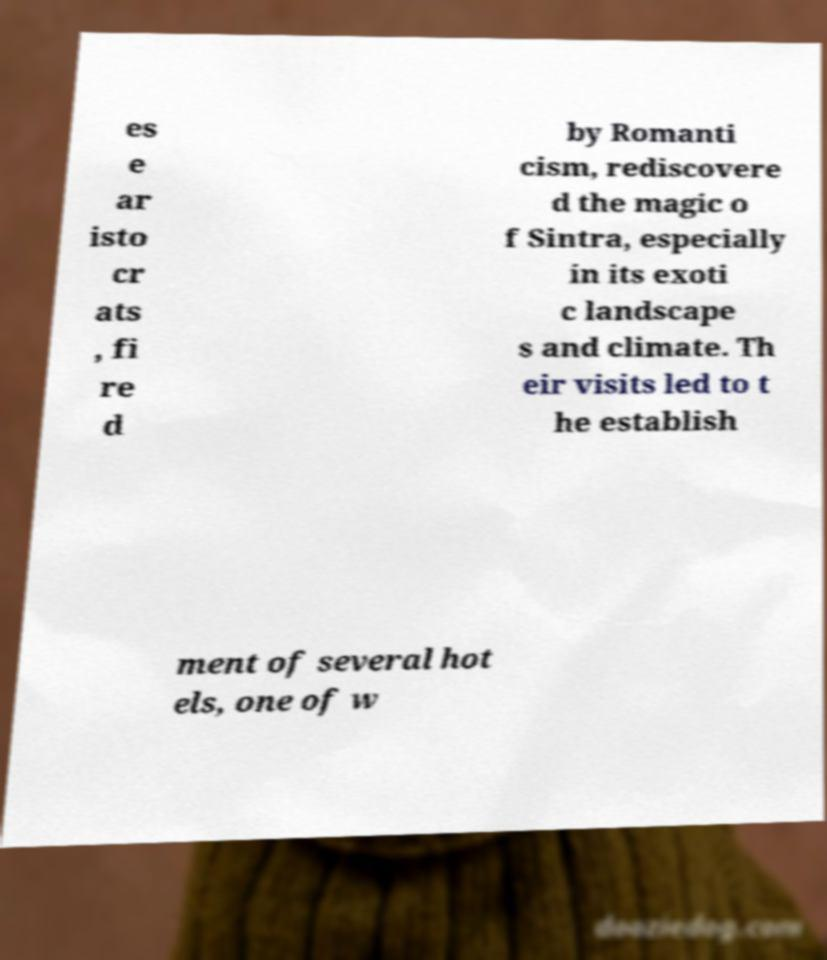Please identify and transcribe the text found in this image. es e ar isto cr ats , fi re d by Romanti cism, rediscovere d the magic o f Sintra, especially in its exoti c landscape s and climate. Th eir visits led to t he establish ment of several hot els, one of w 